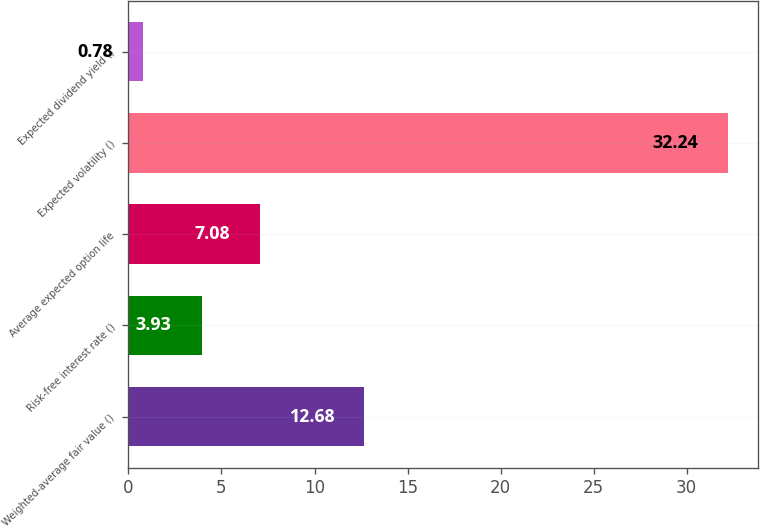<chart> <loc_0><loc_0><loc_500><loc_500><bar_chart><fcel>Weighted-average fair value ()<fcel>Risk-free interest rate ()<fcel>Average expected option life<fcel>Expected volatility ()<fcel>Expected dividend yield ()<nl><fcel>12.68<fcel>3.93<fcel>7.08<fcel>32.24<fcel>0.78<nl></chart> 